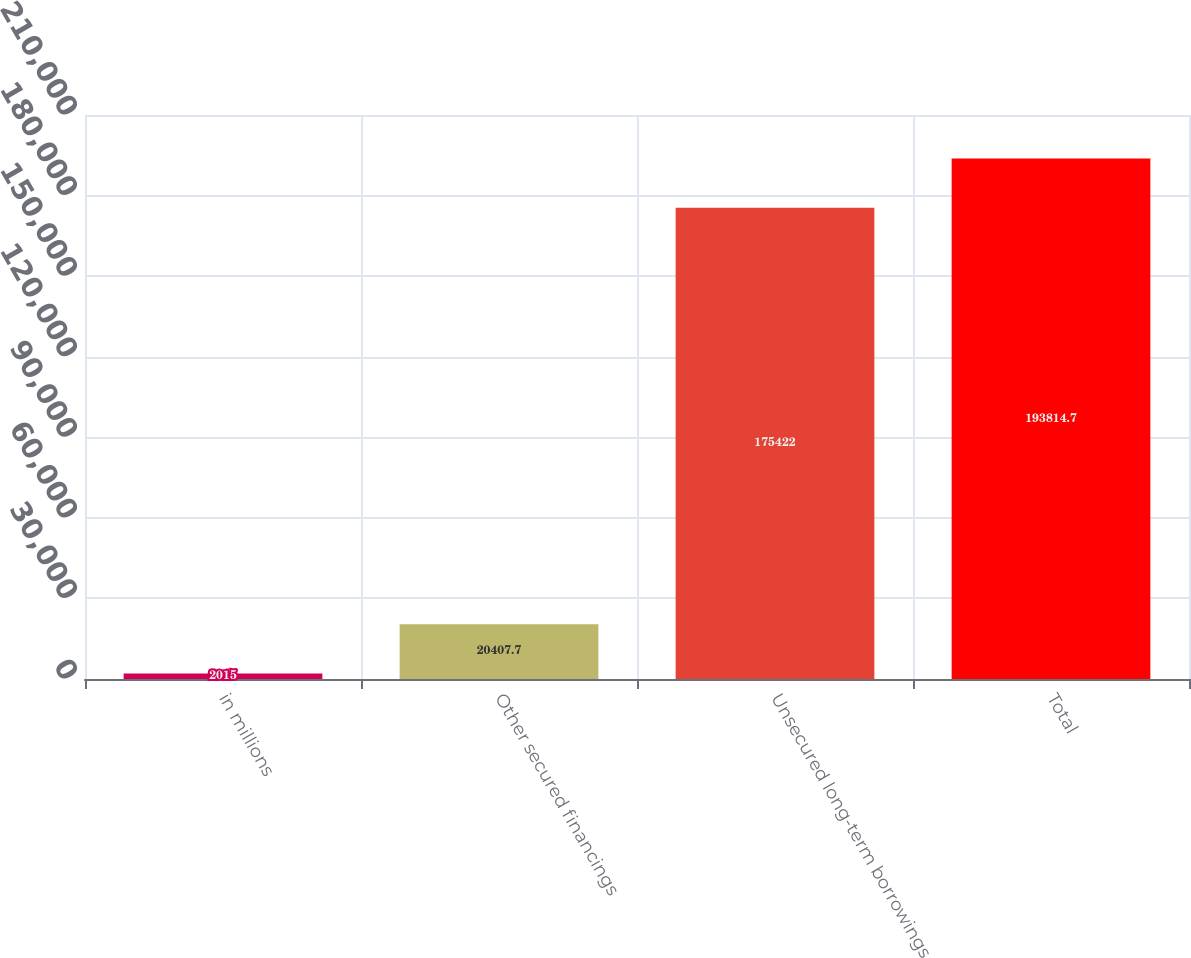Convert chart to OTSL. <chart><loc_0><loc_0><loc_500><loc_500><bar_chart><fcel>in millions<fcel>Other secured financings<fcel>Unsecured long-term borrowings<fcel>Total<nl><fcel>2015<fcel>20407.7<fcel>175422<fcel>193815<nl></chart> 